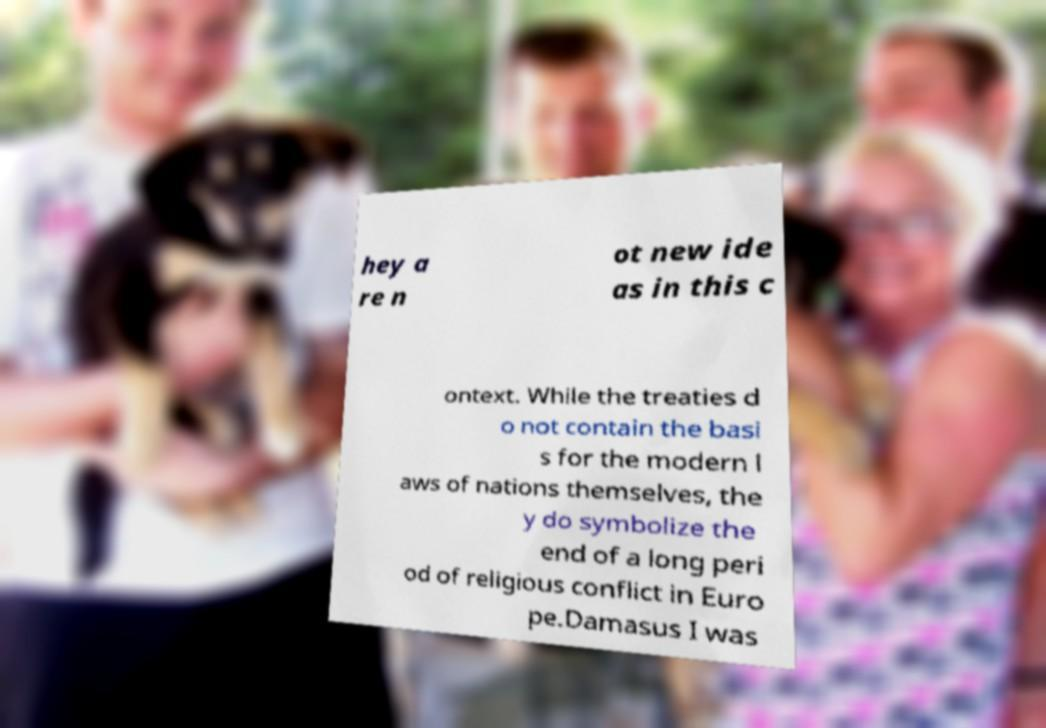For documentation purposes, I need the text within this image transcribed. Could you provide that? hey a re n ot new ide as in this c ontext. While the treaties d o not contain the basi s for the modern l aws of nations themselves, the y do symbolize the end of a long peri od of religious conflict in Euro pe.Damasus I was 